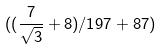Convert formula to latex. <formula><loc_0><loc_0><loc_500><loc_500>( ( \frac { 7 } { \sqrt { 3 } } + 8 ) / 1 9 7 + 8 7 )</formula> 